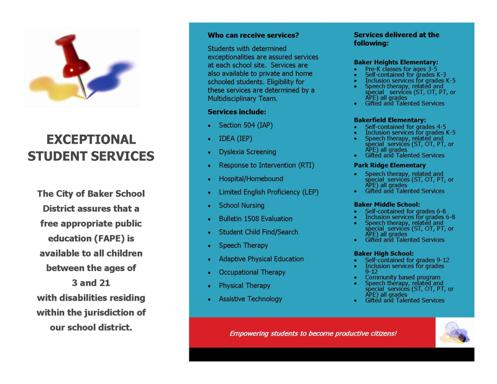Are these services available only at specific schools or all over the district? The services are distributed across all schools within the City of Baker School District, ensuring that no matter where a student with disabilities is enrolled, they have access to necessary supports. Additionally, these services extend to children who are privately or home-schooled, thus covering a broad spectrum of educational settings within the district. 